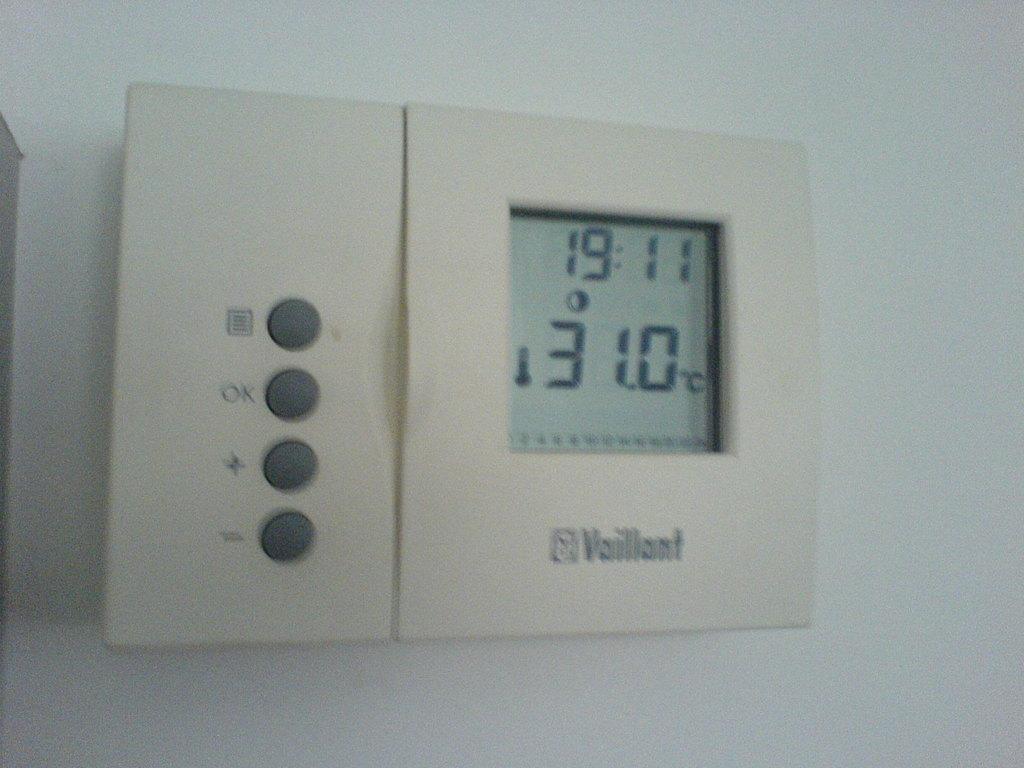What is the temperature on the thermostat?
Ensure brevity in your answer.  31.0. What is the brand seen?
Make the answer very short. Vaillant. 